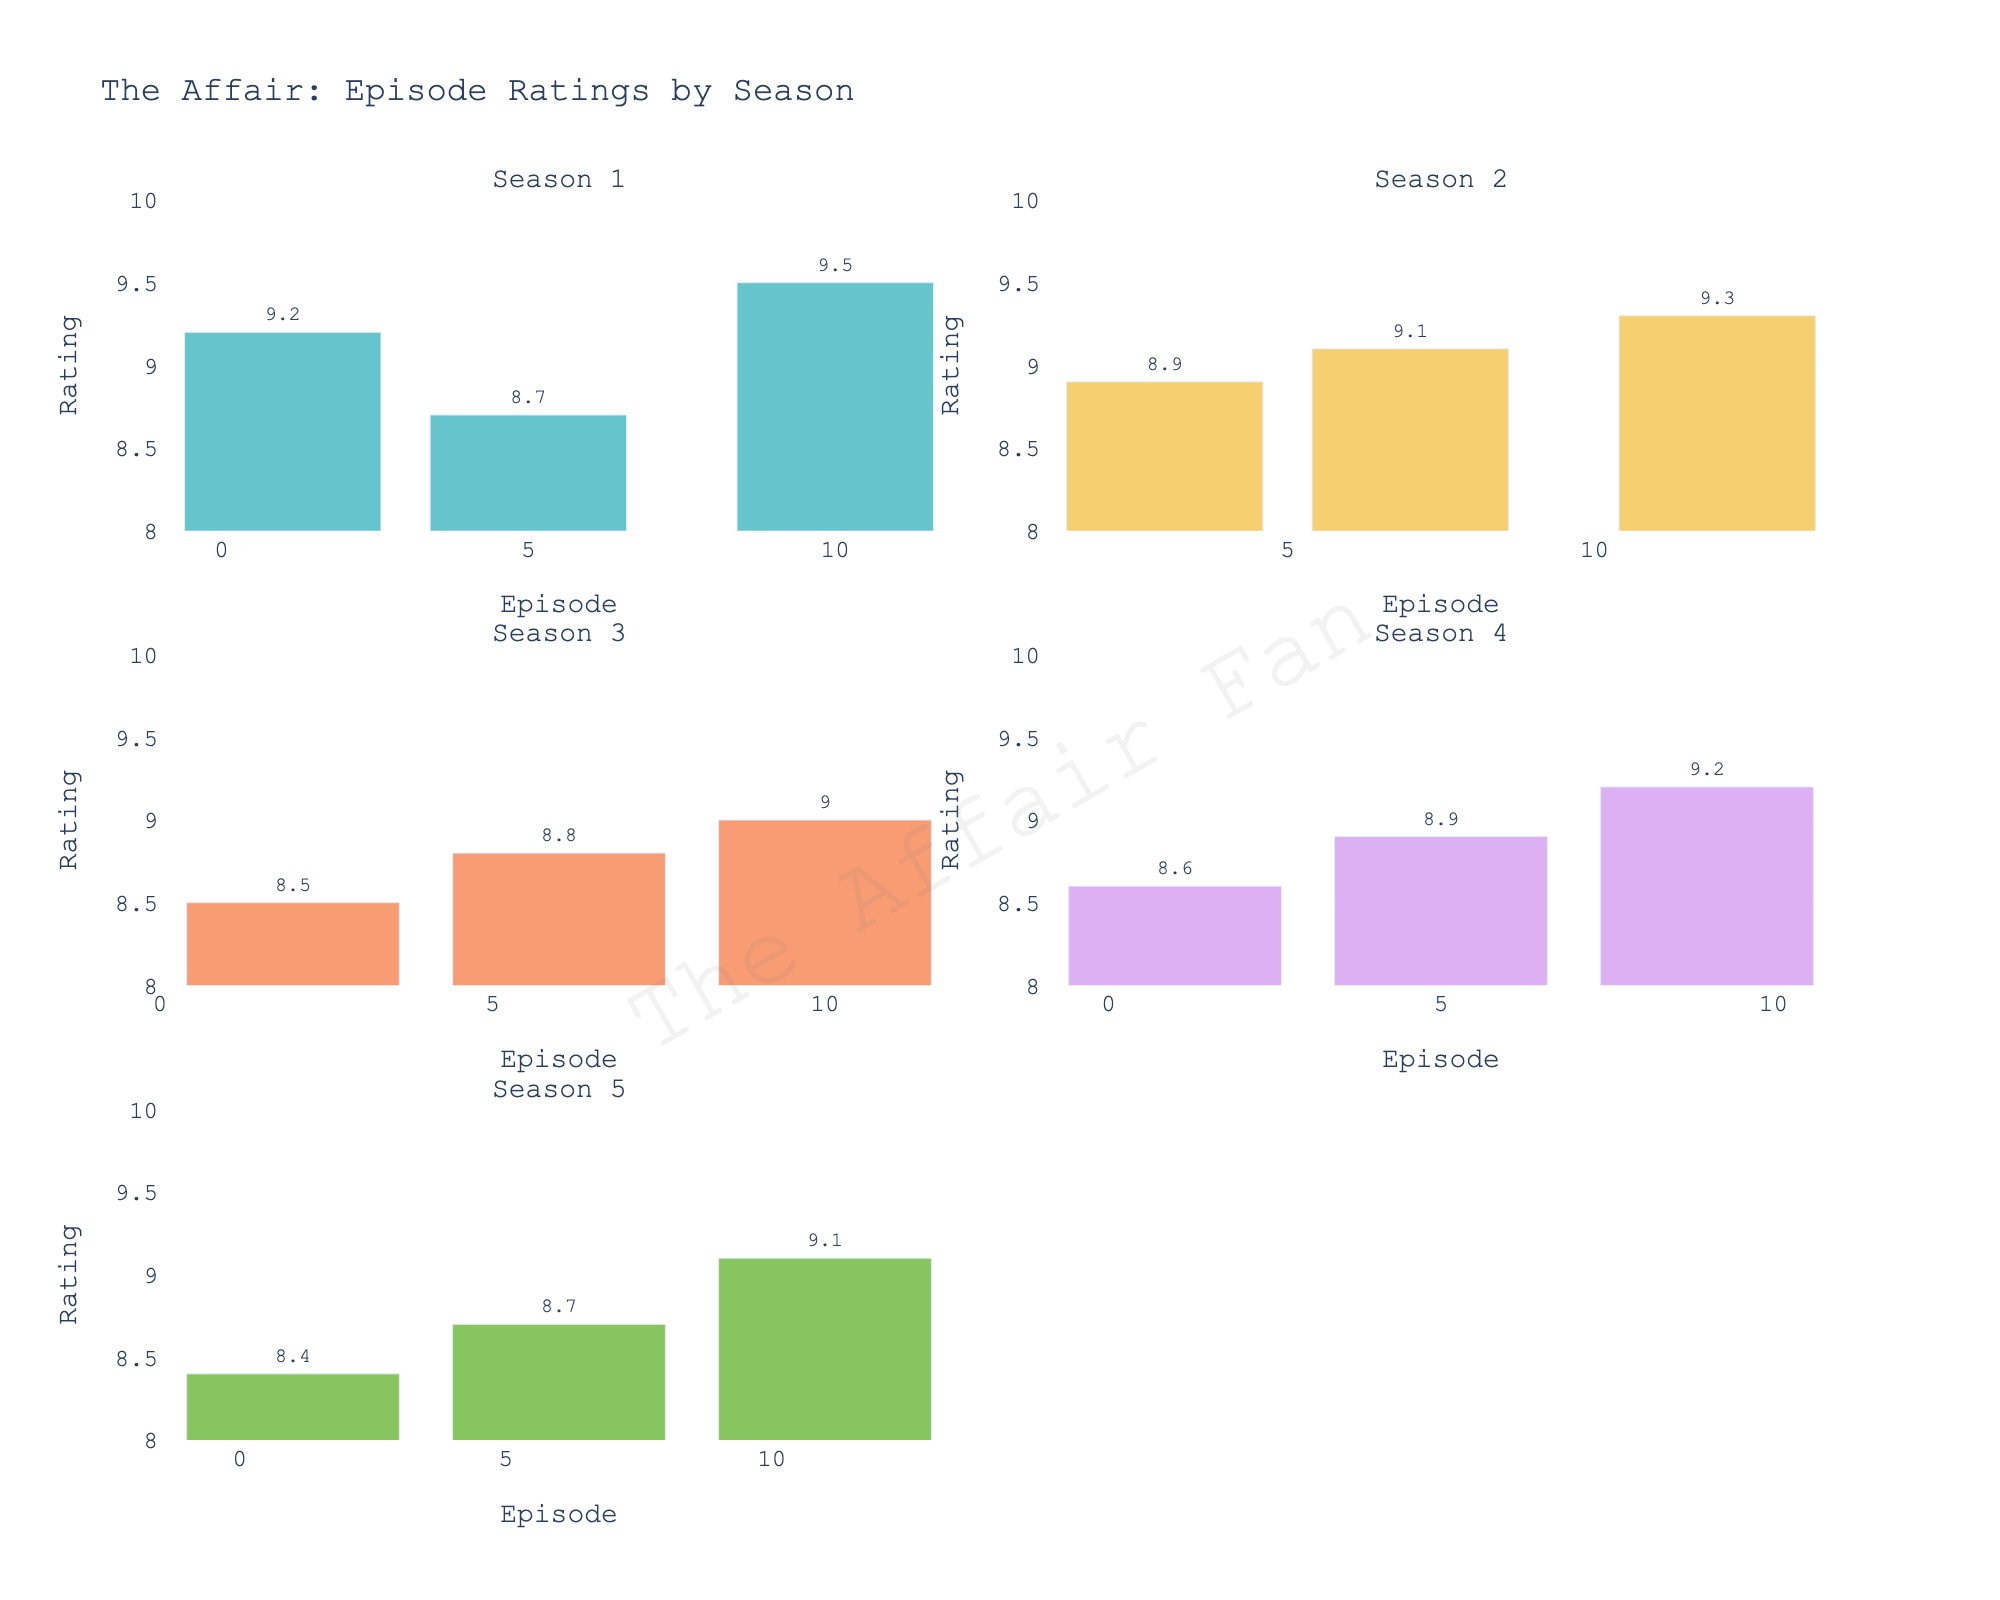What's the highest critical rating in Season 1? To find the highest critical rating in Season 1, look at the critical ratings for all episodes in Season 1 and identify the maximum value.
Answer: 9.5 Which season has the highest average critical rating? Calculate the average critical rating for each season by summing the ratings and dividing by the number of episodes. Compare all the averages to find the highest one.
Answer: Season 2 Which episode in Season 3 has the lowest critical rating? Identify the episode with the lowest critical rating in Season 3 by comparing the ratings of all episodes within that season.
Answer: Episode 2 Compare the highest critical ratings between Season 2 and Season 5. Which one is higher? Find the highest critical rating in Season 2 and Season 5 and compare them to determine which one is higher.
Answer: Season 2 (9.3) How many episodes in Season 4 have a critical rating of 8.9 or higher? Count the number of episodes in Season 4 with a critical rating of 8.9 or higher by looking at each rating and totaling those that meet the criteria.
Answer: 3 What's the difference between the highest and lowest critical ratings in Season 5? Identify the highest and lowest critical ratings in Season 5 and subtract the lowest rating from the highest rating to find the difference.
Answer: 0.7 Is there any season where the critical ratings are always higher than Season 3's highest rating? Compare the highest critical rating of Season 3 with all the ratings in each season. Identify if there is any season where all ratings are higher than Season 3's highest rating.
Answer: No Which episode in Season 2 received the highest critical rating? Find and identify the episode in Season 2 with the highest critical rating by comparing all the ratings in that season.
Answer: Episode 12 What's the average critical rating in Season 3? Calculate the average critical rating by summing all episode ratings in Season 3 and dividing by the number of episodes in that season.
Answer: 8.77 